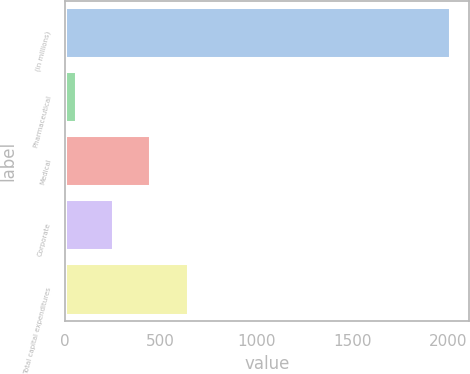Convert chart to OTSL. <chart><loc_0><loc_0><loc_500><loc_500><bar_chart><fcel>(in millions)<fcel>Pharmaceutical<fcel>Medical<fcel>Corporate<fcel>Total capital expenditures<nl><fcel>2011<fcel>55<fcel>446.2<fcel>250.6<fcel>641.8<nl></chart> 